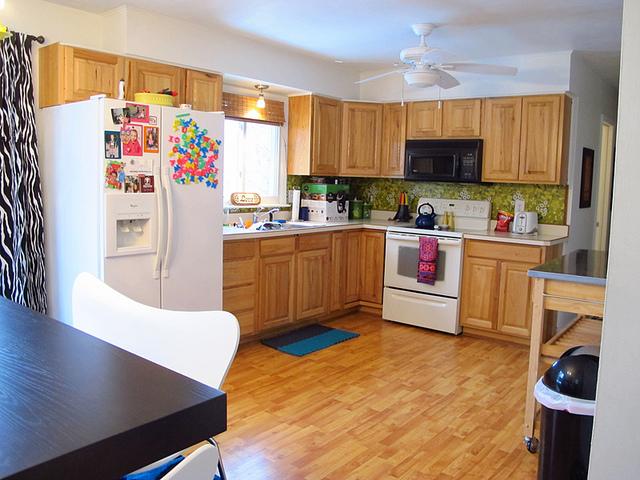What room is it?
Quick response, please. Kitchen. How many cupboards are there?
Write a very short answer. 16. What color is the mat on the floor in front of the sink?
Give a very brief answer. Blue. 